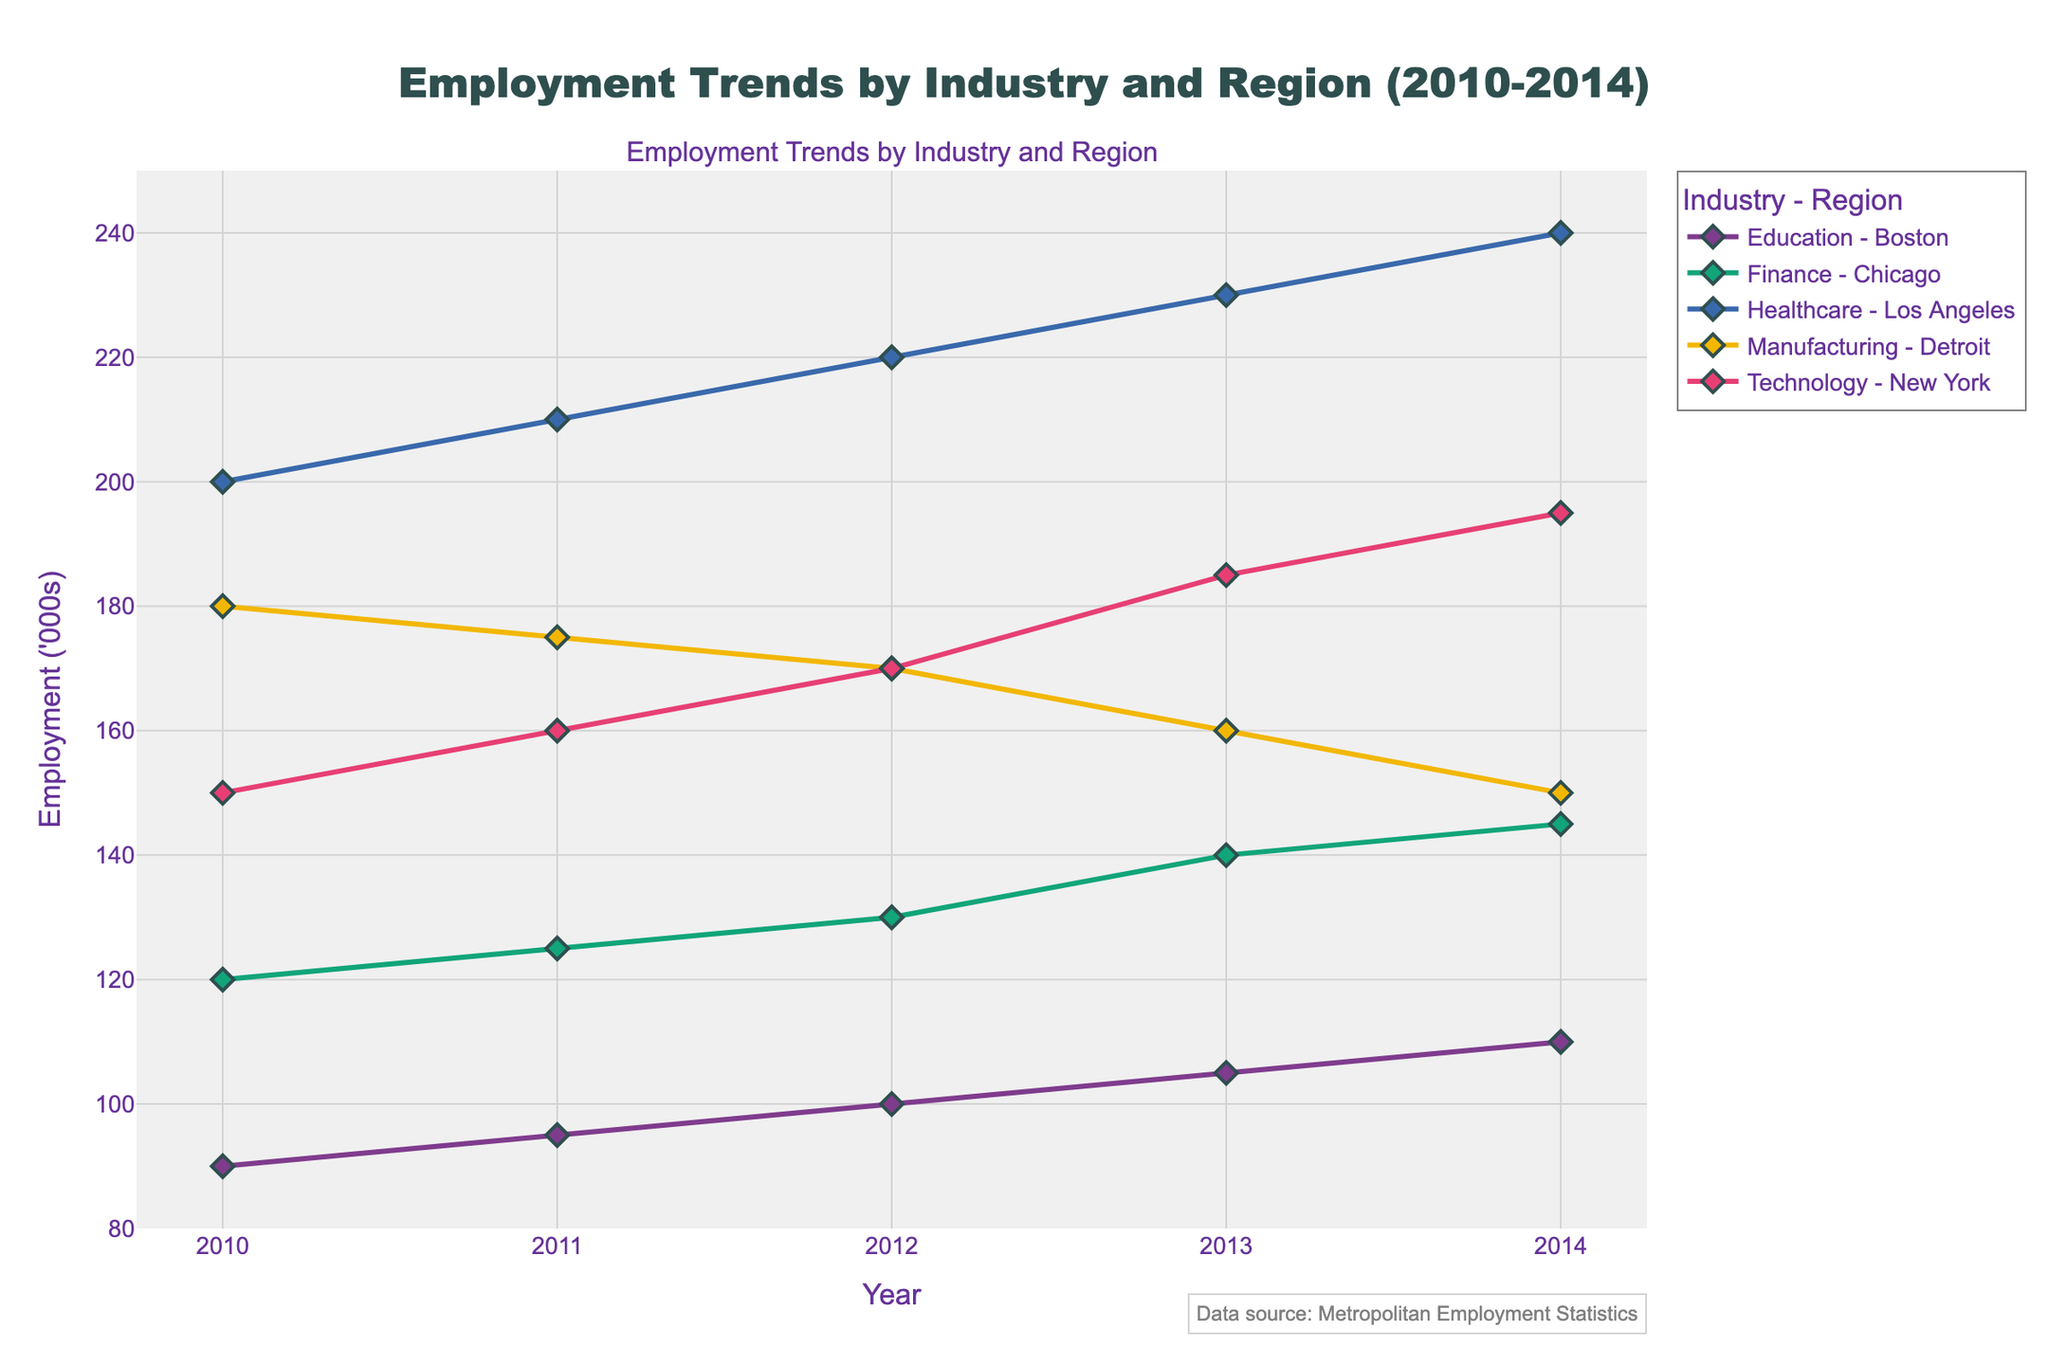what is the title of the figure? The title is located at the top center of the figure. The text is usually larger and bolder than other annotations in the figure.
Answer: Employment Trends by Industry and Region (2010-2014) Which industry-region combination has the highest employment in 2014? Look for the highest y-value in 2014 and trace which line corresponds to that peak.
Answer: Healthcare - Los Angeles How has employment in the manufacturing sector in Detroit changed from 2010 to 2014? Check the starting value for Manufacturing in Detroit in 2010 and compare it to the ending value in 2014.
Answer: Decreased What is the average employment in the Finance sector in Chicago from 2010 to 2014? Sum the employment values for the Finance sector in Chicago for each year and divide by the number of years (5). Calculation: (120 + 125 + 130 + 140 + 145) / 5 = 132
Answer: 132 Which industry saw a constant increase in employment each year from 2010 to 2014? Identify which lines on the plot have a positive slope every year without any decreases.
Answer: Technology - New York Compare the employment trends in Technology in New York and Manufacturing in Detroit. Who had a more significant change from 2010 to 2014? Calculate the change for both: Technology in New York (195 - 150 = 45), Manufacturing in Detroit (180 - 150 = -30). Technology in New York has a larger change.
Answer: Technology - New York What is the difference in employment between Healthcare in Los Angeles and Education in Boston in 2012? Find the employment values for Healthcare in Los Angeles and Education in Boston in 2012 and subtract the latter from the former. Calculation: 220 - 100 = 120
Answer: 120 Which industry-region experienced a decline in employment over the years? Look for lines with a downward slope from 2010 to 2014.
Answer: Manufacturing - Detroit How many years did Education in Boston have an employment figure under 100,000? Identify the points on the line representing Education in Boston to see how many years the values are below 100,000. 2010, 2011 show values under 100.
Answer: 2 What is the range of employment in the Technology sector in New York over the period 2010-2014? Find the minimum and maximum employment values for Technology in New York from 2010 to 2014, then calculate the range: Maximum (195) - Minimum (150) = 45.
Answer: 45 